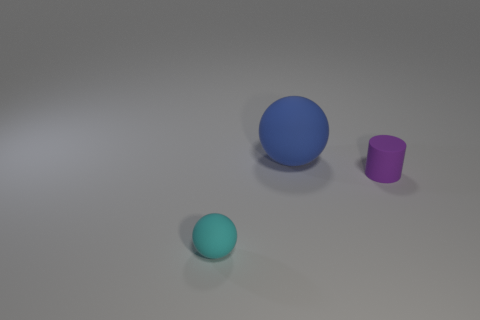Add 2 big blue objects. How many objects exist? 5 Subtract all spheres. How many objects are left? 1 Subtract all big green metal cylinders. Subtract all blue matte objects. How many objects are left? 2 Add 1 tiny purple cylinders. How many tiny purple cylinders are left? 2 Add 1 large purple cylinders. How many large purple cylinders exist? 1 Subtract 0 red blocks. How many objects are left? 3 